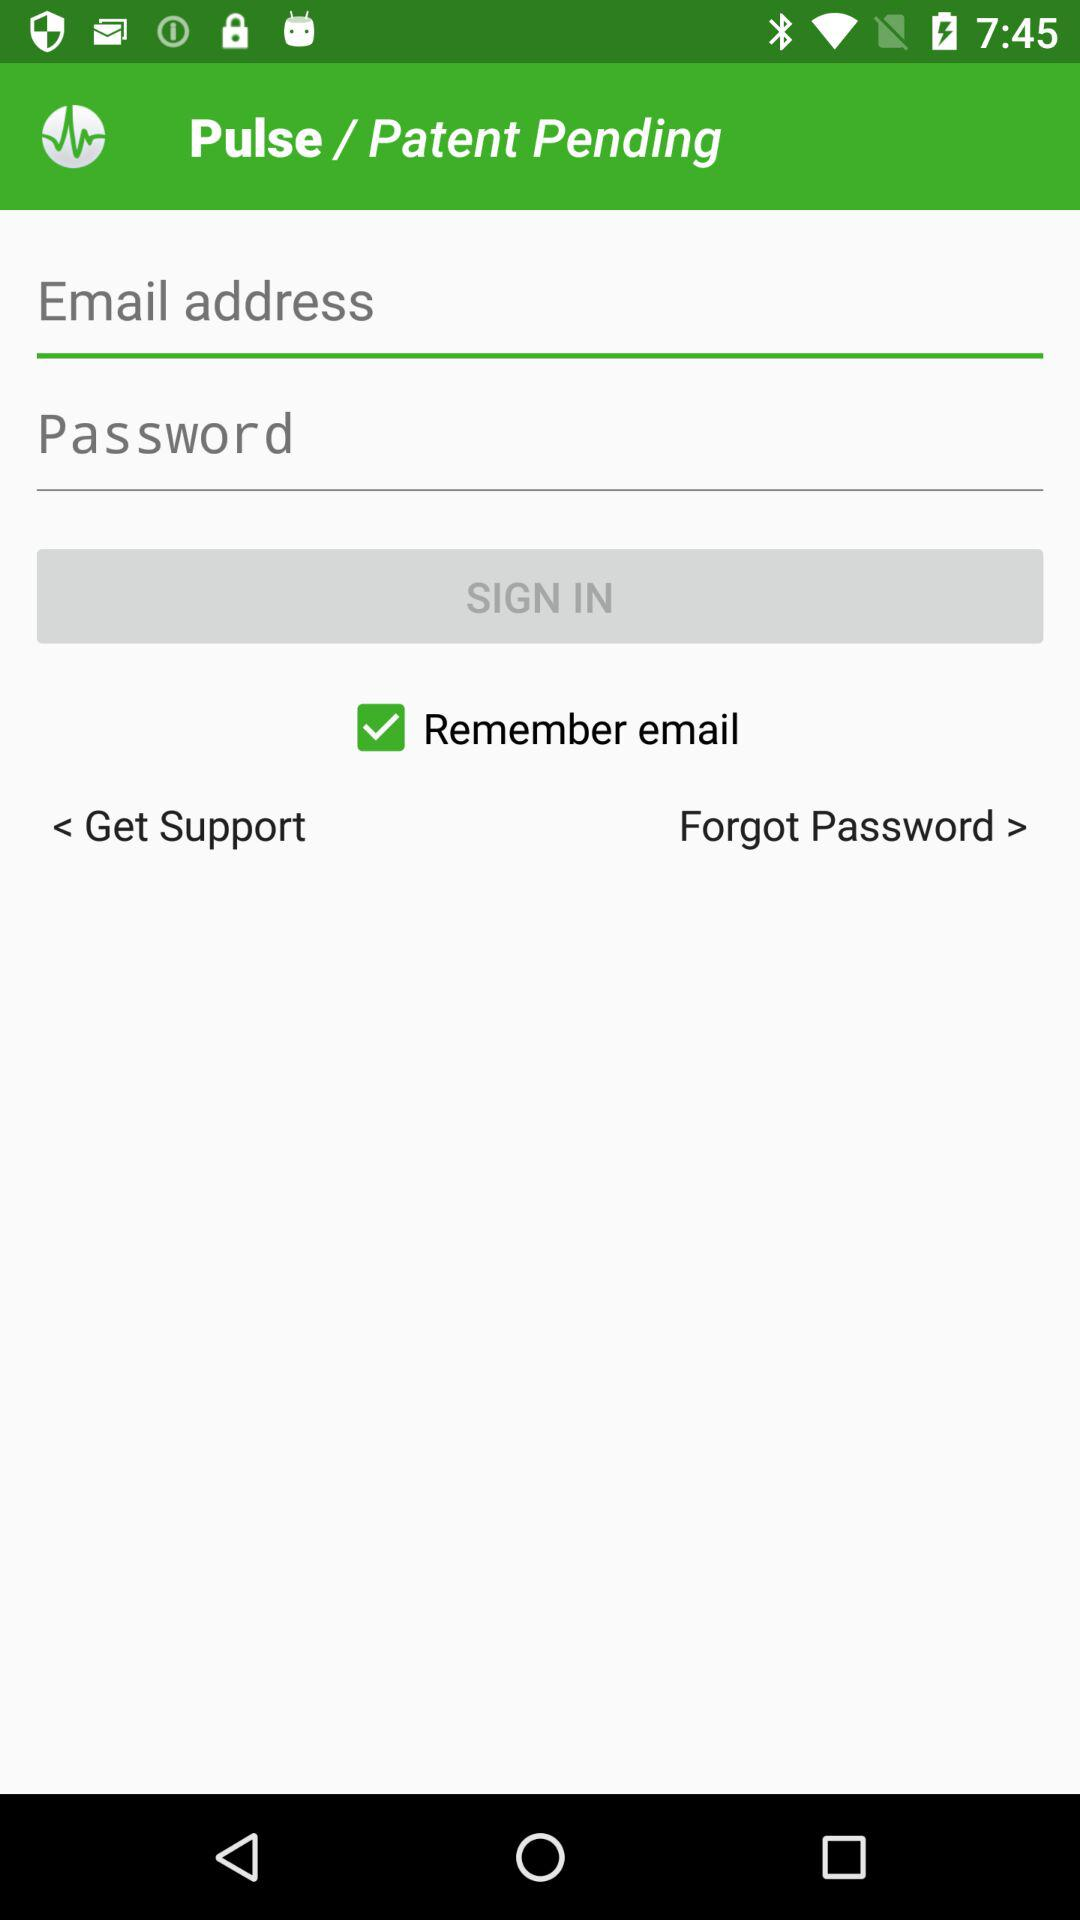What is the status of the "Remember email"? The status is "on". 